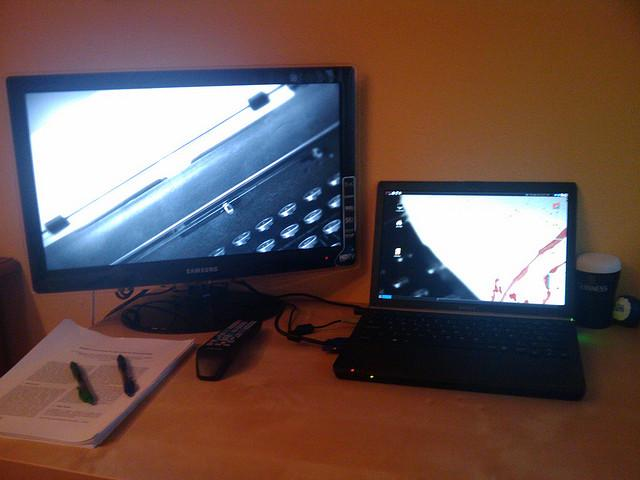By which technology standard is the monitor connected to the laptop?

Choices:
A) vga
B) dvi
C) displayport
D) hdmi vga 